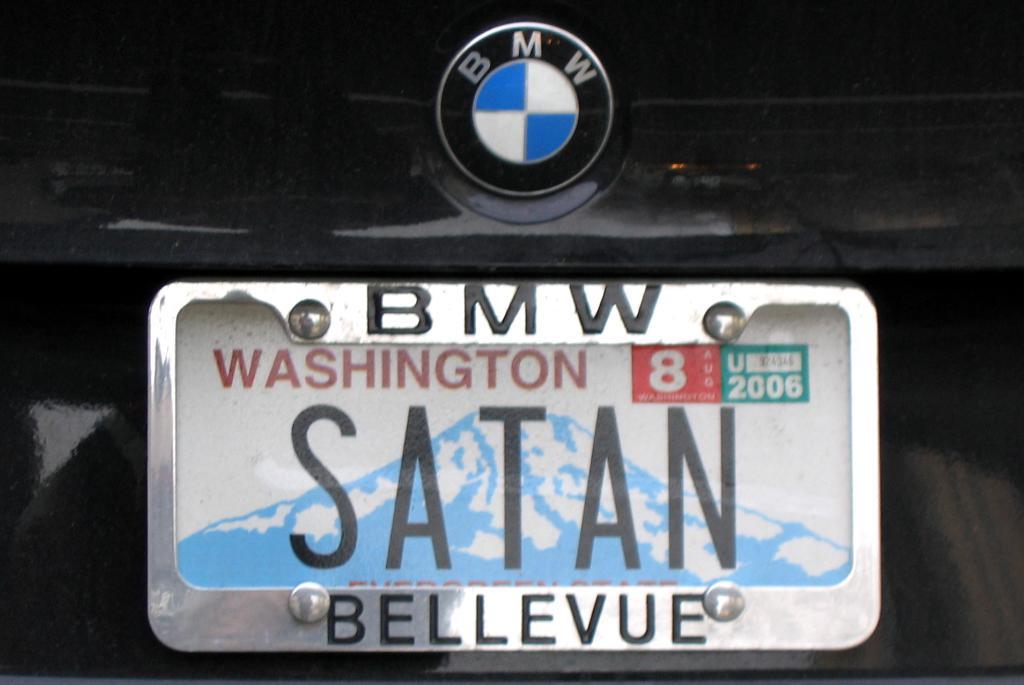What name is on the plate?
Make the answer very short. Satan. 